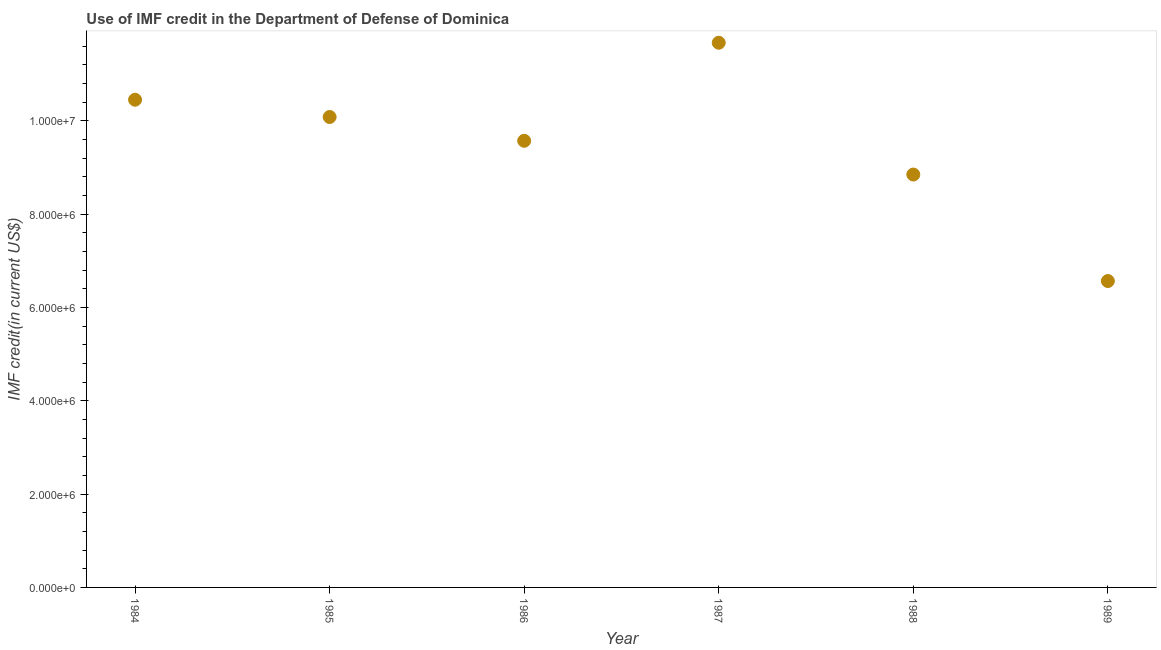What is the use of imf credit in dod in 1987?
Provide a short and direct response. 1.17e+07. Across all years, what is the maximum use of imf credit in dod?
Keep it short and to the point. 1.17e+07. Across all years, what is the minimum use of imf credit in dod?
Offer a terse response. 6.56e+06. What is the sum of the use of imf credit in dod?
Offer a very short reply. 5.72e+07. What is the difference between the use of imf credit in dod in 1987 and 1988?
Ensure brevity in your answer.  2.82e+06. What is the average use of imf credit in dod per year?
Your response must be concise. 9.53e+06. What is the median use of imf credit in dod?
Provide a short and direct response. 9.82e+06. Do a majority of the years between 1984 and 1989 (inclusive) have use of imf credit in dod greater than 3600000 US$?
Your response must be concise. Yes. What is the ratio of the use of imf credit in dod in 1984 to that in 1985?
Your answer should be compact. 1.04. Is the use of imf credit in dod in 1984 less than that in 1985?
Offer a very short reply. No. Is the difference between the use of imf credit in dod in 1984 and 1986 greater than the difference between any two years?
Offer a terse response. No. What is the difference between the highest and the second highest use of imf credit in dod?
Your answer should be compact. 1.22e+06. Is the sum of the use of imf credit in dod in 1986 and 1987 greater than the maximum use of imf credit in dod across all years?
Provide a succinct answer. Yes. What is the difference between the highest and the lowest use of imf credit in dod?
Offer a very short reply. 5.11e+06. In how many years, is the use of imf credit in dod greater than the average use of imf credit in dod taken over all years?
Offer a very short reply. 4. How many years are there in the graph?
Ensure brevity in your answer.  6. Are the values on the major ticks of Y-axis written in scientific E-notation?
Keep it short and to the point. Yes. Does the graph contain any zero values?
Provide a succinct answer. No. Does the graph contain grids?
Your answer should be compact. No. What is the title of the graph?
Your answer should be compact. Use of IMF credit in the Department of Defense of Dominica. What is the label or title of the Y-axis?
Provide a succinct answer. IMF credit(in current US$). What is the IMF credit(in current US$) in 1984?
Keep it short and to the point. 1.04e+07. What is the IMF credit(in current US$) in 1985?
Provide a succinct answer. 1.01e+07. What is the IMF credit(in current US$) in 1986?
Provide a short and direct response. 9.57e+06. What is the IMF credit(in current US$) in 1987?
Make the answer very short. 1.17e+07. What is the IMF credit(in current US$) in 1988?
Your answer should be very brief. 8.85e+06. What is the IMF credit(in current US$) in 1989?
Provide a short and direct response. 6.56e+06. What is the difference between the IMF credit(in current US$) in 1984 and 1986?
Offer a very short reply. 8.80e+05. What is the difference between the IMF credit(in current US$) in 1984 and 1987?
Offer a very short reply. -1.22e+06. What is the difference between the IMF credit(in current US$) in 1984 and 1988?
Provide a succinct answer. 1.60e+06. What is the difference between the IMF credit(in current US$) in 1984 and 1989?
Keep it short and to the point. 3.88e+06. What is the difference between the IMF credit(in current US$) in 1985 and 1986?
Your answer should be compact. 5.10e+05. What is the difference between the IMF credit(in current US$) in 1985 and 1987?
Your answer should be very brief. -1.59e+06. What is the difference between the IMF credit(in current US$) in 1985 and 1988?
Your answer should be very brief. 1.23e+06. What is the difference between the IMF credit(in current US$) in 1985 and 1989?
Keep it short and to the point. 3.52e+06. What is the difference between the IMF credit(in current US$) in 1986 and 1987?
Your response must be concise. -2.10e+06. What is the difference between the IMF credit(in current US$) in 1986 and 1988?
Your answer should be compact. 7.23e+05. What is the difference between the IMF credit(in current US$) in 1986 and 1989?
Offer a terse response. 3.00e+06. What is the difference between the IMF credit(in current US$) in 1987 and 1988?
Offer a terse response. 2.82e+06. What is the difference between the IMF credit(in current US$) in 1987 and 1989?
Offer a terse response. 5.11e+06. What is the difference between the IMF credit(in current US$) in 1988 and 1989?
Make the answer very short. 2.28e+06. What is the ratio of the IMF credit(in current US$) in 1984 to that in 1986?
Provide a succinct answer. 1.09. What is the ratio of the IMF credit(in current US$) in 1984 to that in 1987?
Offer a terse response. 0.9. What is the ratio of the IMF credit(in current US$) in 1984 to that in 1988?
Provide a short and direct response. 1.18. What is the ratio of the IMF credit(in current US$) in 1984 to that in 1989?
Ensure brevity in your answer.  1.59. What is the ratio of the IMF credit(in current US$) in 1985 to that in 1986?
Your answer should be very brief. 1.05. What is the ratio of the IMF credit(in current US$) in 1985 to that in 1987?
Your response must be concise. 0.86. What is the ratio of the IMF credit(in current US$) in 1985 to that in 1988?
Your response must be concise. 1.14. What is the ratio of the IMF credit(in current US$) in 1985 to that in 1989?
Your answer should be very brief. 1.53. What is the ratio of the IMF credit(in current US$) in 1986 to that in 1987?
Your response must be concise. 0.82. What is the ratio of the IMF credit(in current US$) in 1986 to that in 1988?
Provide a succinct answer. 1.08. What is the ratio of the IMF credit(in current US$) in 1986 to that in 1989?
Provide a short and direct response. 1.46. What is the ratio of the IMF credit(in current US$) in 1987 to that in 1988?
Offer a terse response. 1.32. What is the ratio of the IMF credit(in current US$) in 1987 to that in 1989?
Offer a terse response. 1.78. What is the ratio of the IMF credit(in current US$) in 1988 to that in 1989?
Your answer should be compact. 1.35. 